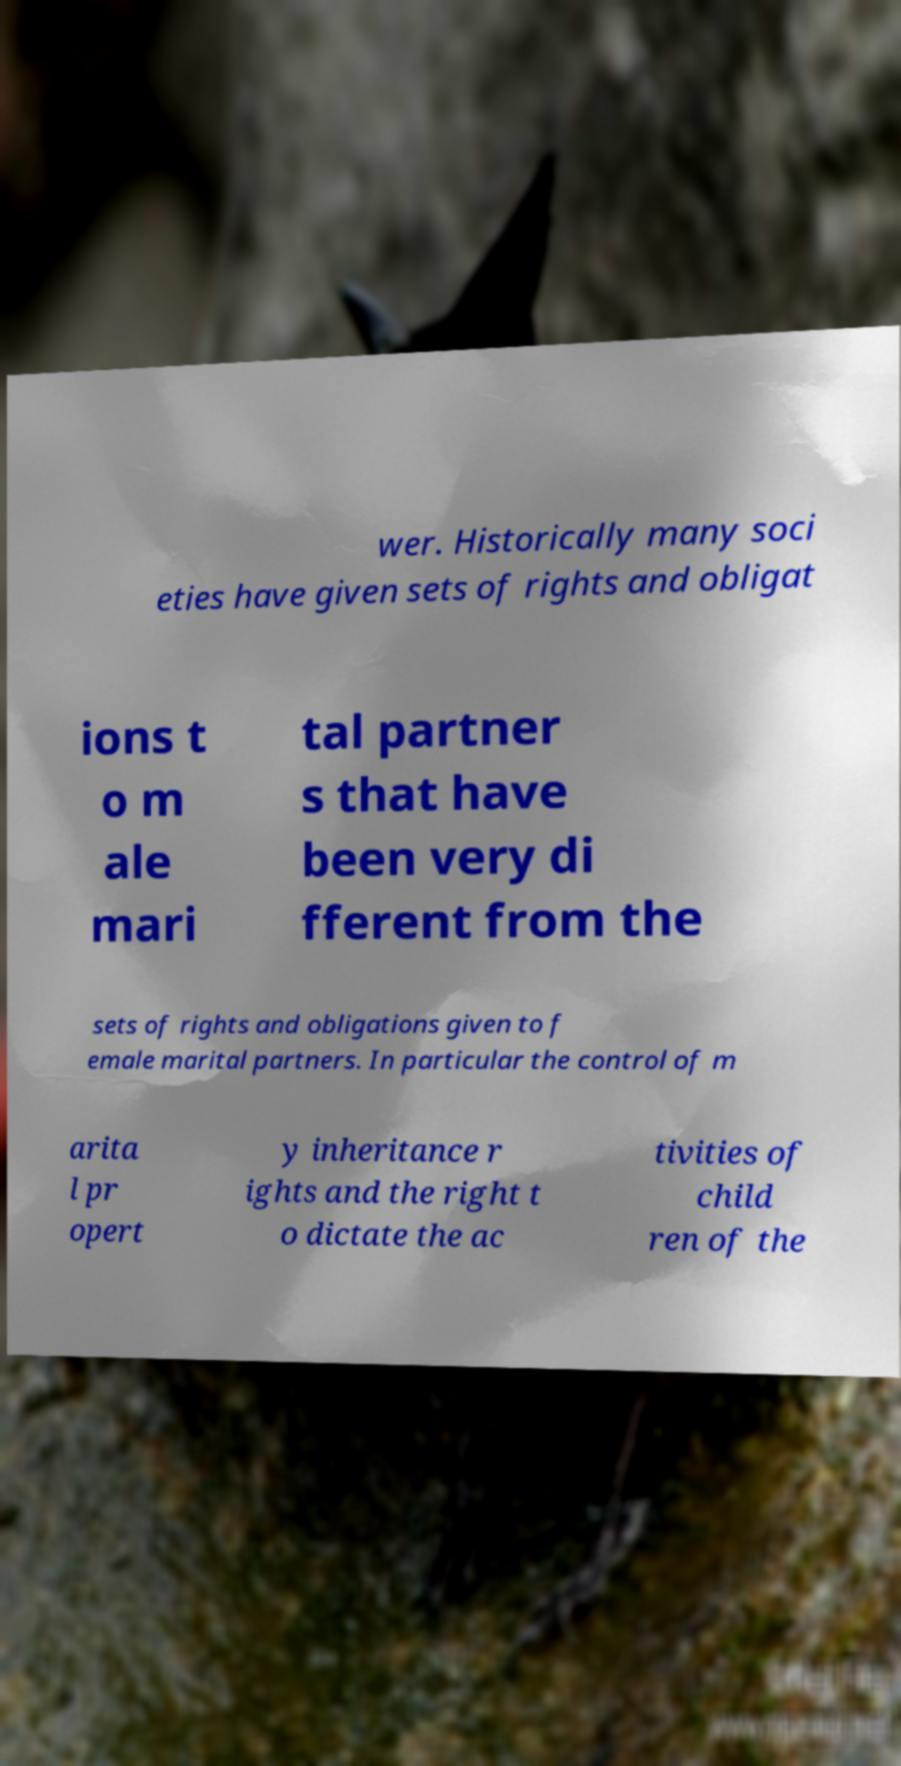Can you accurately transcribe the text from the provided image for me? wer. Historically many soci eties have given sets of rights and obligat ions t o m ale mari tal partner s that have been very di fferent from the sets of rights and obligations given to f emale marital partners. In particular the control of m arita l pr opert y inheritance r ights and the right t o dictate the ac tivities of child ren of the 